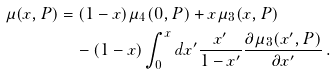<formula> <loc_0><loc_0><loc_500><loc_500>\mu ( x , P ) & = ( 1 - x ) \mu _ { 4 } ( 0 , P ) + x \mu _ { 3 } ( x , P ) \\ & \quad - ( 1 - x ) \int _ { 0 } ^ { x } d x ^ { \prime } \frac { x ^ { \prime } } { 1 - x ^ { \prime } } \frac { \partial \mu _ { 3 } ( x ^ { \prime } , P ) } { \partial x ^ { \prime } } \, .</formula> 